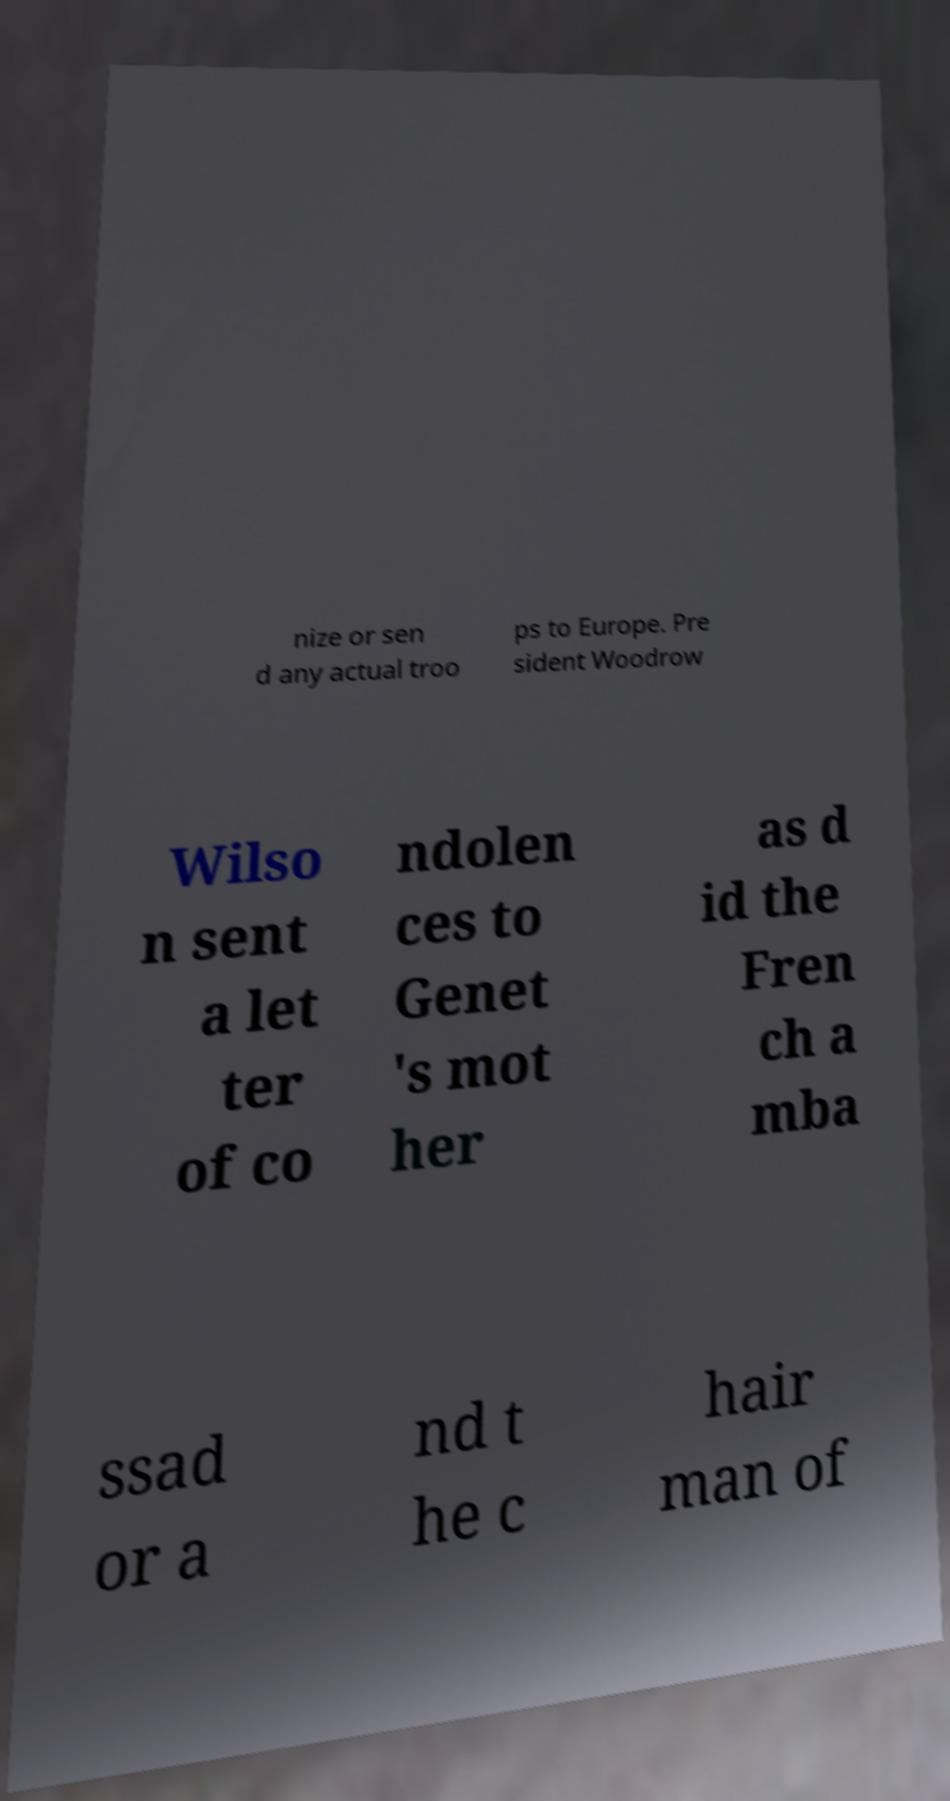Can you read and provide the text displayed in the image?This photo seems to have some interesting text. Can you extract and type it out for me? nize or sen d any actual troo ps to Europe. Pre sident Woodrow Wilso n sent a let ter of co ndolen ces to Genet 's mot her as d id the Fren ch a mba ssad or a nd t he c hair man of 